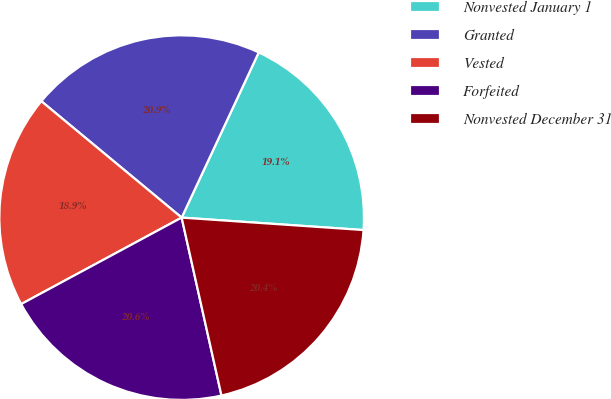Convert chart to OTSL. <chart><loc_0><loc_0><loc_500><loc_500><pie_chart><fcel>Nonvested January 1<fcel>Granted<fcel>Vested<fcel>Forfeited<fcel>Nonvested December 31<nl><fcel>19.14%<fcel>20.93%<fcel>18.89%<fcel>20.64%<fcel>20.41%<nl></chart> 